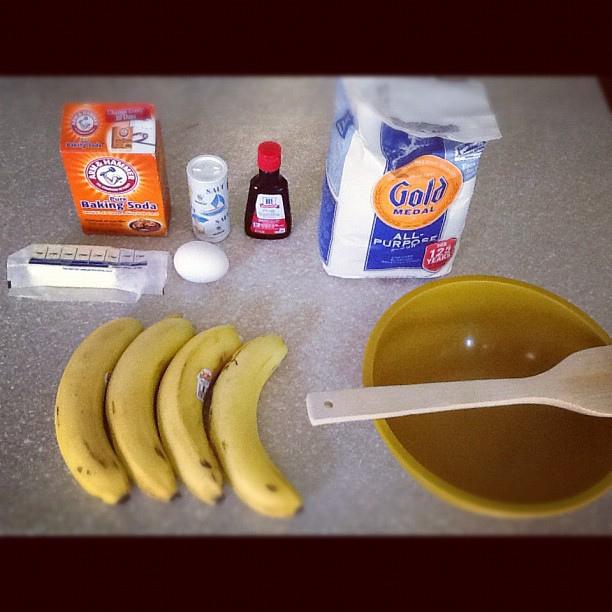What is the brand of the baking soda?
Be succinct. Arm & hammer. What is between the salt and flour?
Give a very brief answer. Vanilla extract. What is the purpose of the ingredients pictured here?
Give a very brief answer. Banana bread. 